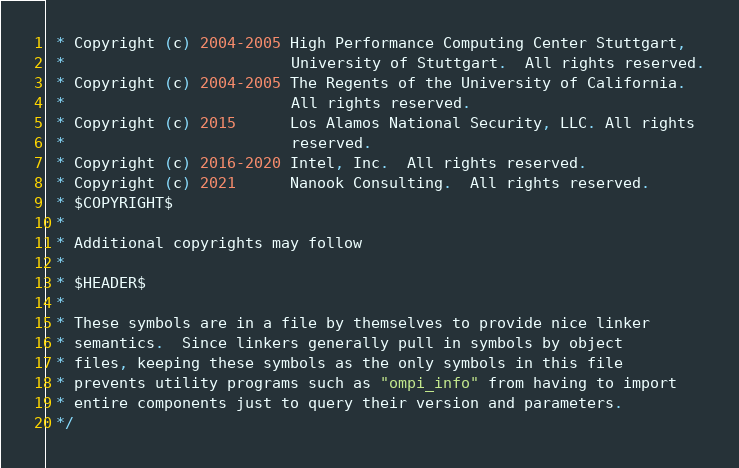<code> <loc_0><loc_0><loc_500><loc_500><_C_> * Copyright (c) 2004-2005 High Performance Computing Center Stuttgart,
 *                         University of Stuttgart.  All rights reserved.
 * Copyright (c) 2004-2005 The Regents of the University of California.
 *                         All rights reserved.
 * Copyright (c) 2015      Los Alamos National Security, LLC. All rights
 *                         reserved.
 * Copyright (c) 2016-2020 Intel, Inc.  All rights reserved.
 * Copyright (c) 2021      Nanook Consulting.  All rights reserved.
 * $COPYRIGHT$
 *
 * Additional copyrights may follow
 *
 * $HEADER$
 *
 * These symbols are in a file by themselves to provide nice linker
 * semantics.  Since linkers generally pull in symbols by object
 * files, keeping these symbols as the only symbols in this file
 * prevents utility programs such as "ompi_info" from having to import
 * entire components just to query their version and parameters.
 */
</code> 